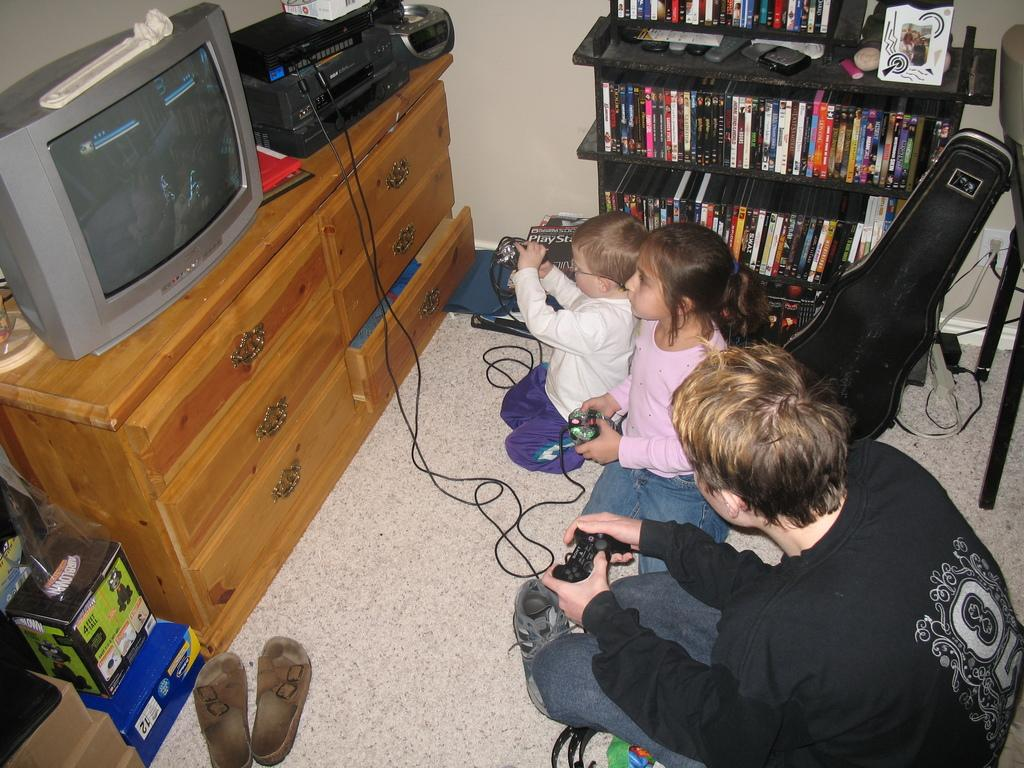How many people are in the image? There is a group of persons in the image. What are the people in the image doing? The group of persons are playing games. What electronic devices can be seen on the left side of the image? There is a television and a radio on the left side of the image. What type of secretary can be seen in the image? There is no secretary present in the image. What smell is associated with the game being played in the image? The image does not provide any information about smells or scents. 